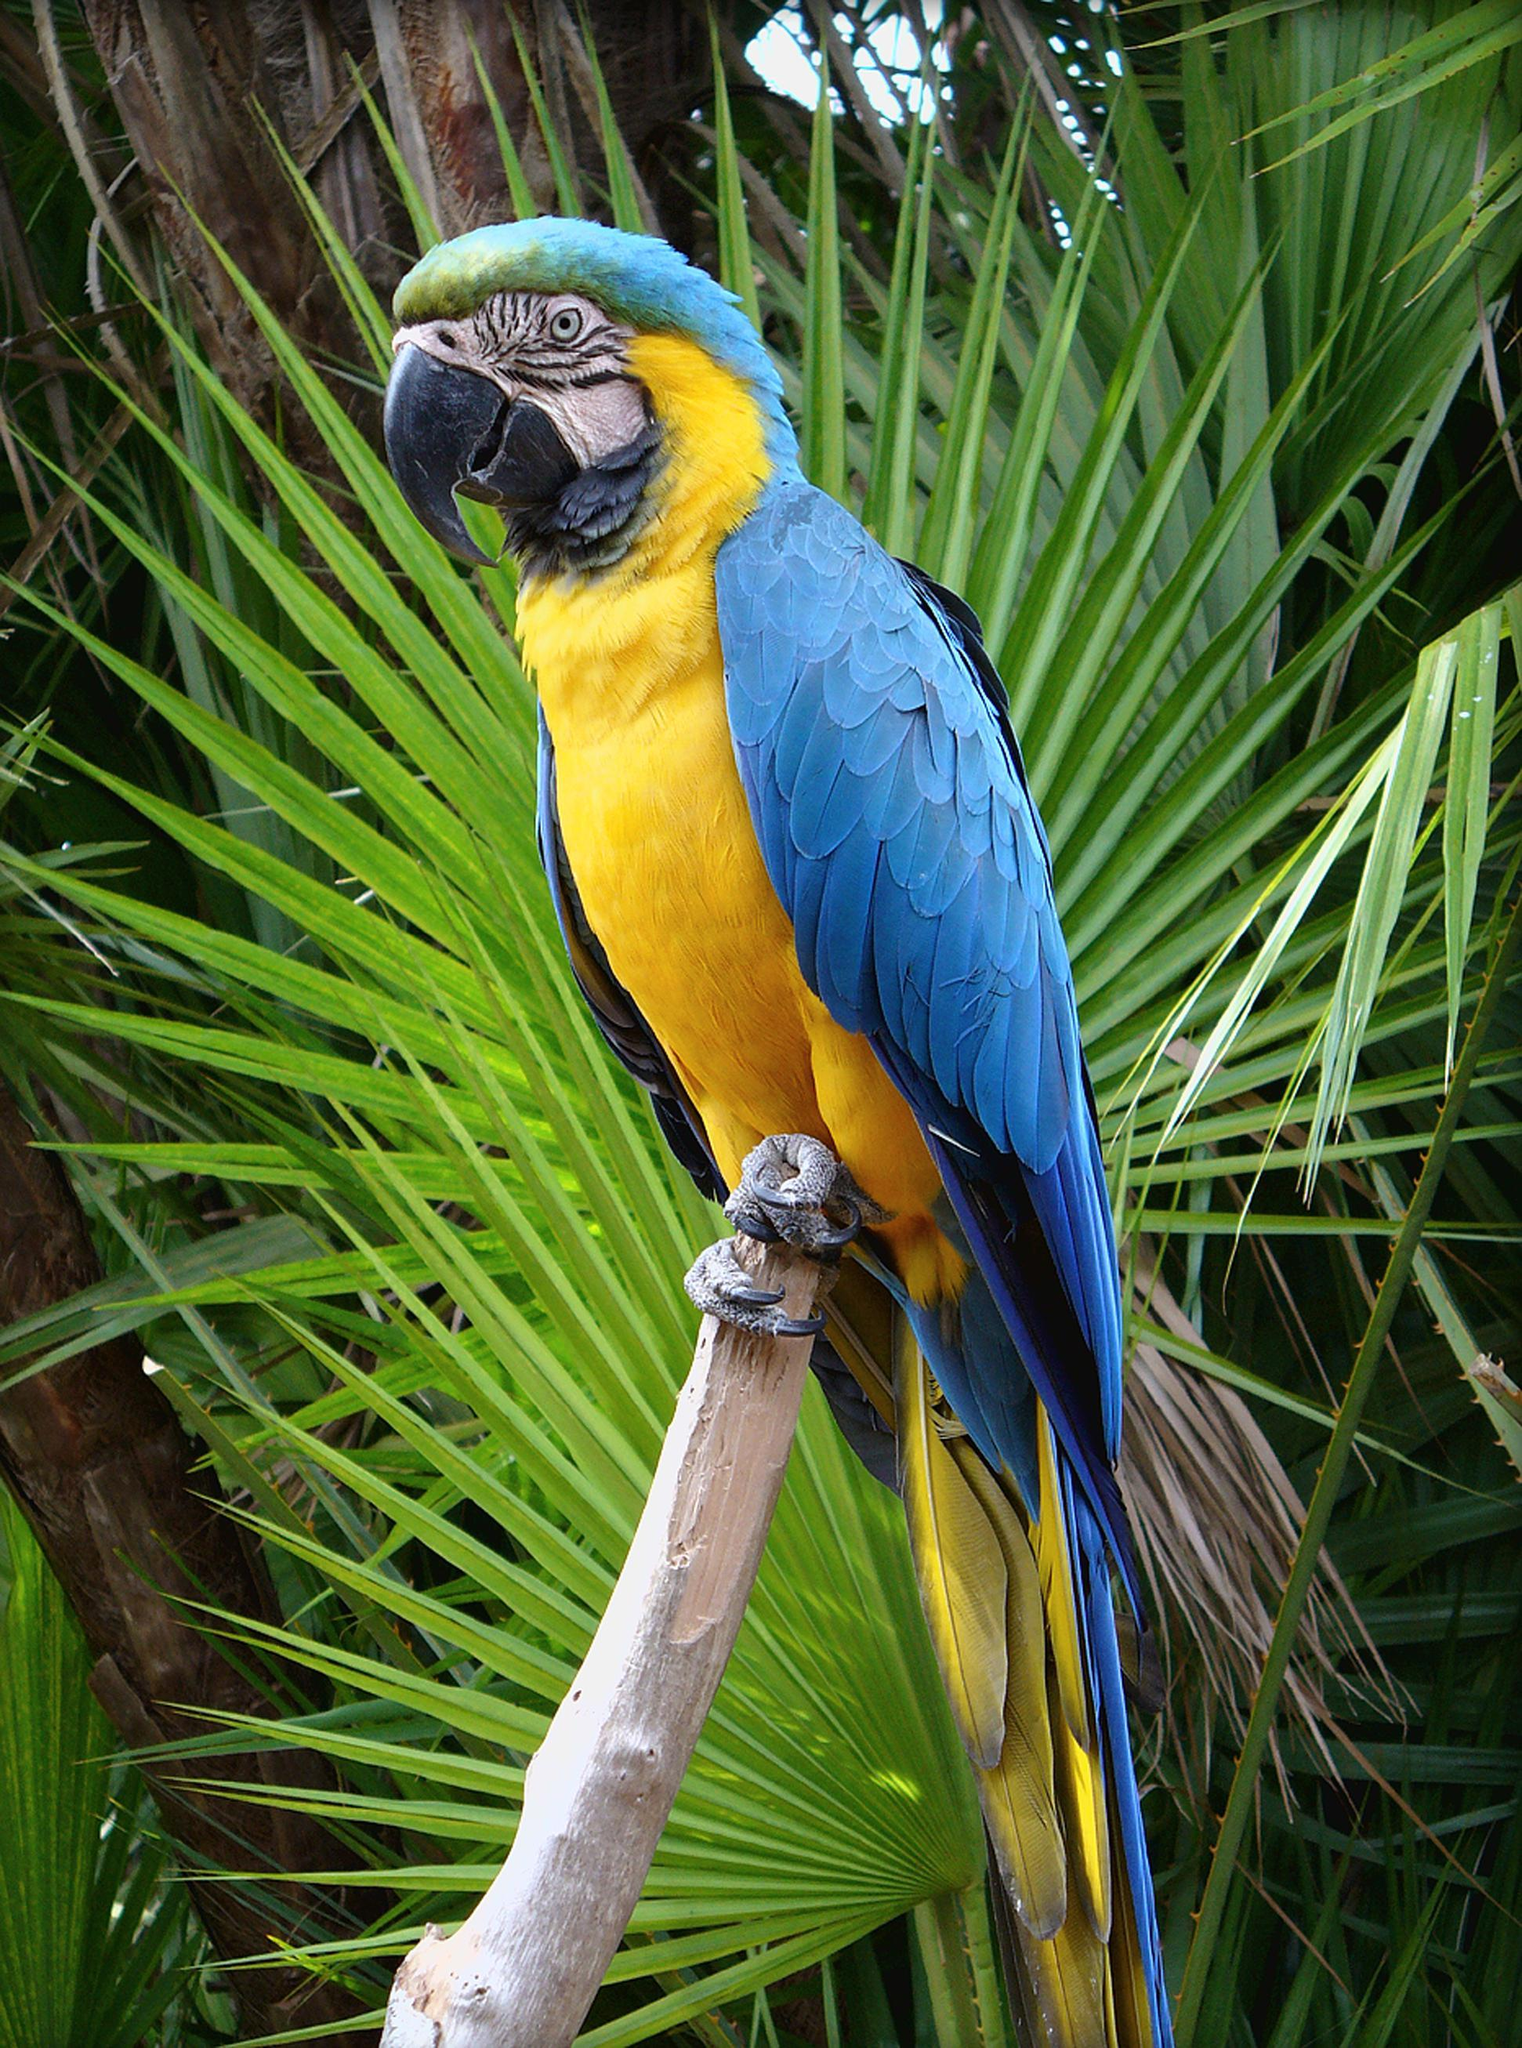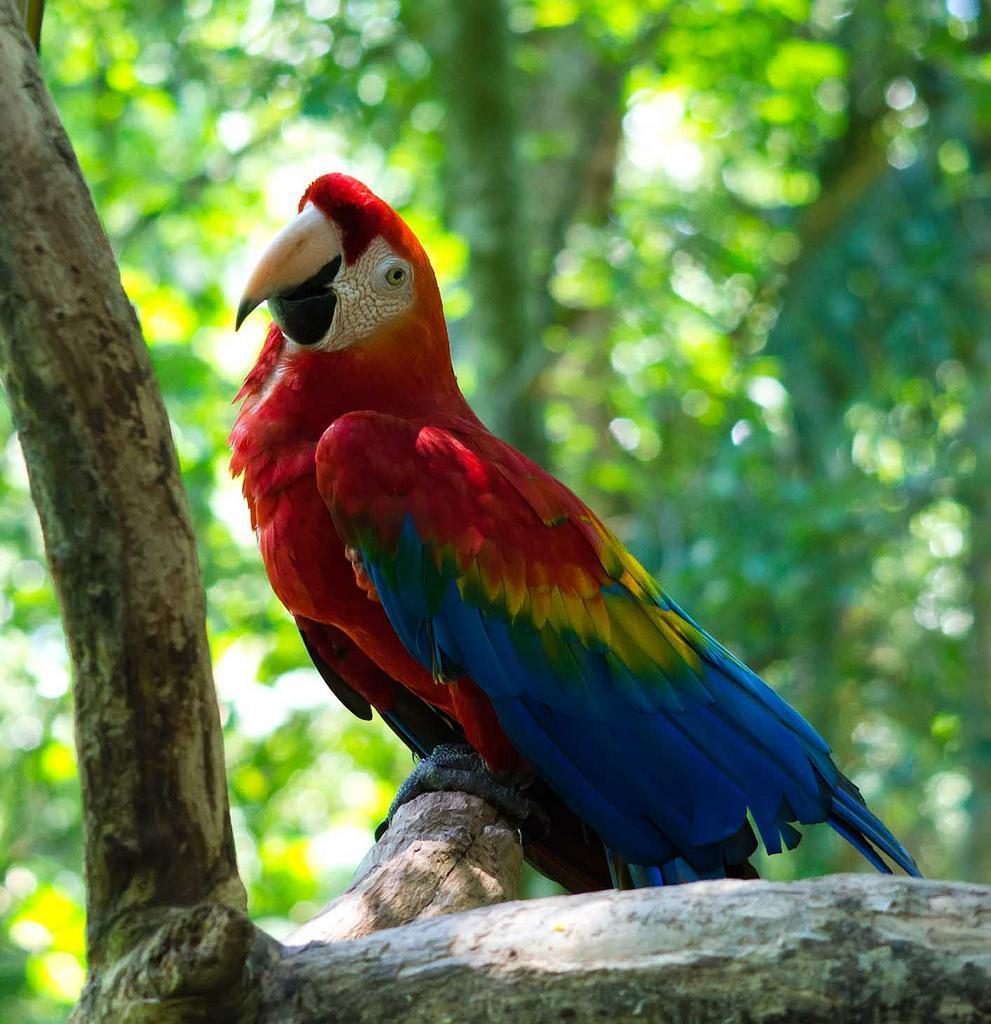The first image is the image on the left, the second image is the image on the right. Examine the images to the left and right. Is the description "One image contains a bird with spread wings, and the other image shows a perching bird with a red head." accurate? Answer yes or no. No. The first image is the image on the left, the second image is the image on the right. Analyze the images presented: Is the assertion "The bird in the image on the right has its wings spread." valid? Answer yes or no. No. 